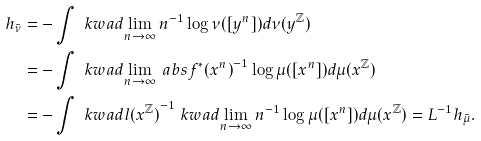Convert formula to latex. <formula><loc_0><loc_0><loc_500><loc_500>h _ { \bar { \nu } } & = - \int \ k w a d { \lim _ { n \rightarrow \infty } n ^ { - 1 } \log \nu ( [ y ^ { n } ] ) } d \nu ( { y } ^ { \mathbb { Z } } ) \\ & = - \int \ k w a d { \lim _ { n \rightarrow \infty } \ a b s { f ^ { * } ( x ^ { n } ) } ^ { - 1 } \log \mu ( [ x ^ { n } ] ) } d \mu ( { x } ^ { \mathbb { Z } } ) \\ & = - \int \ k w a d { l ( { x } ^ { \mathbb { Z } } ) } ^ { - 1 } \ k w a d { \lim _ { n \rightarrow \infty } n ^ { - 1 } \log \mu ( [ x ^ { n } ] ) } d \mu ( { x } ^ { \mathbb { Z } } ) = L ^ { - 1 } h _ { \bar { \mu } } .</formula> 